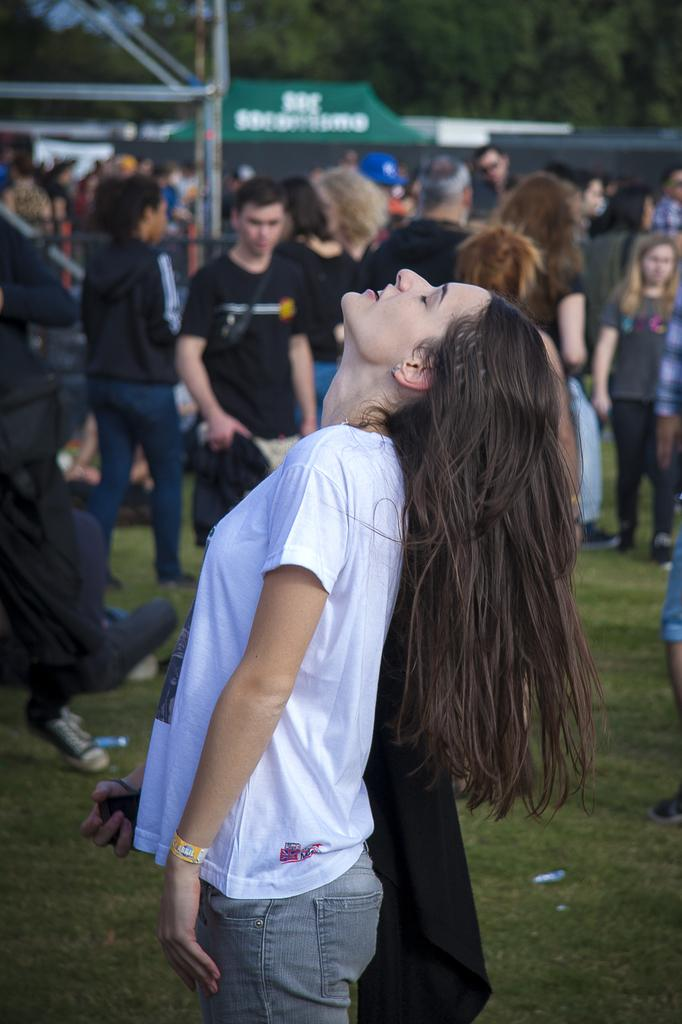What is happening in the image? There are groups of people standing in the image. What type of surface is at the bottom of the image? There is grass at the bottom of the image. What can be seen in the background of the image? There is a building and trees in the background of the image. Where is the mailbox located in the image? There is no mailbox present in the image. What color is the thumb of the person in the image? There are no visible thumbs or people's hands in the image. 